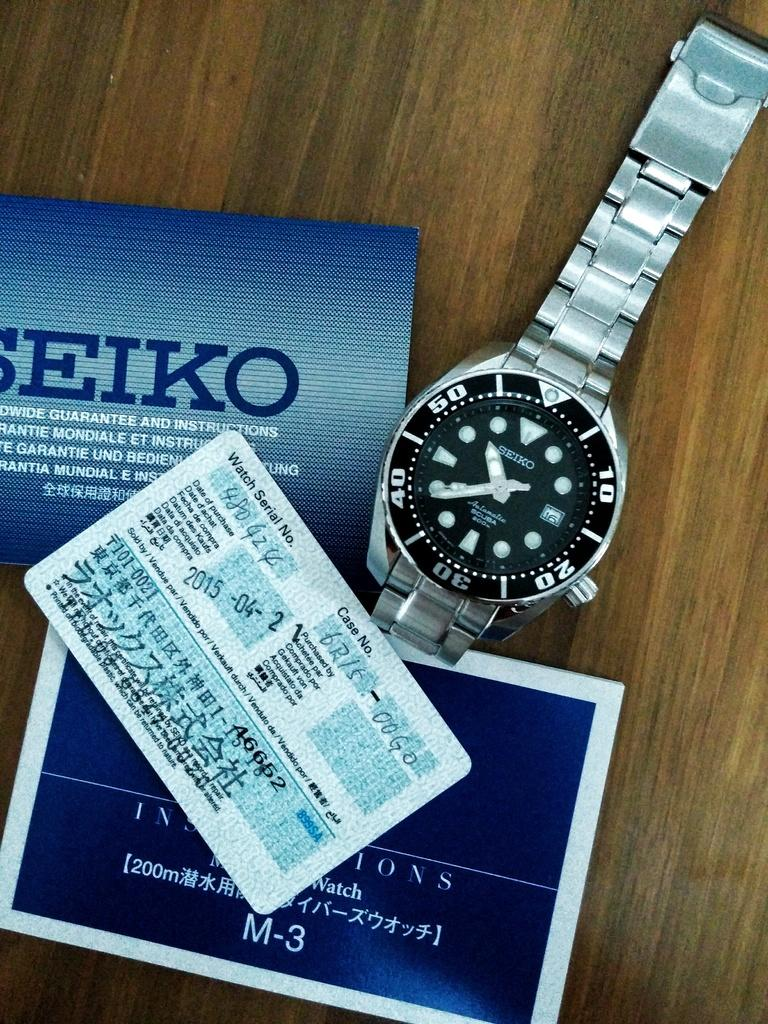<image>
Relay a brief, clear account of the picture shown. A watch with papers on the table with the word Seiko on it. 